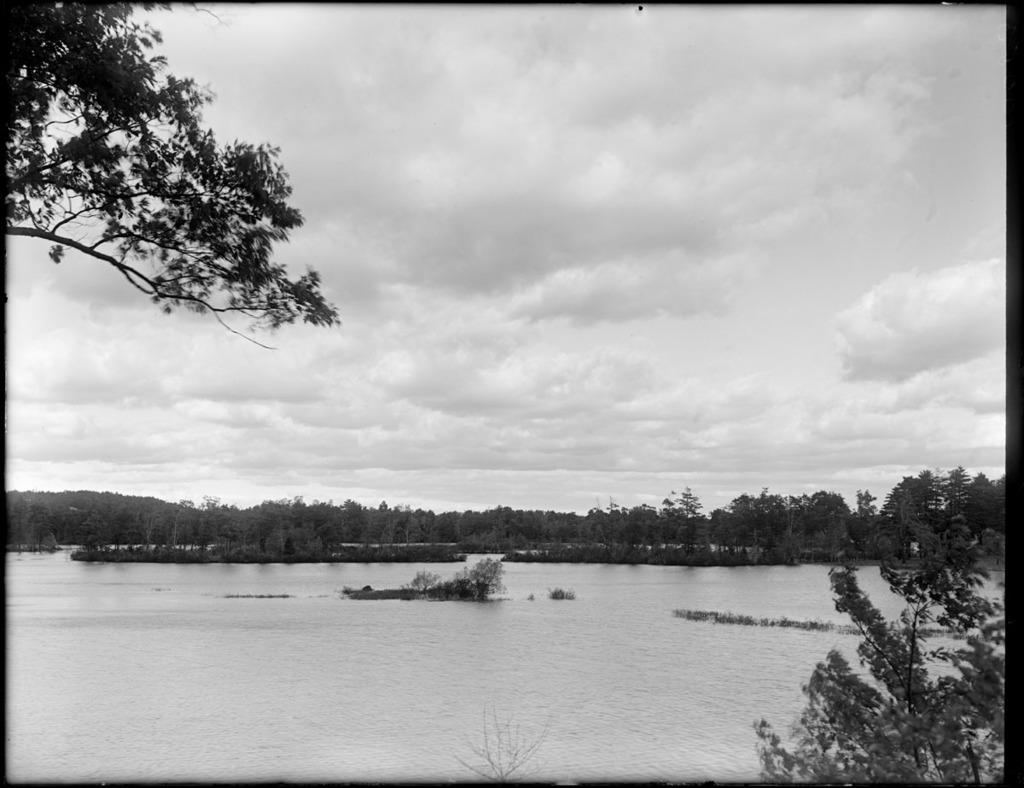What is the primary element visible in the picture? There is water in the picture. What can be seen in the background of the picture? There are trees in the background of the picture. How many turkeys are visible in the picture? There are no turkeys present in the picture; it only features water and trees in the background. What type of pleasure can be experienced by the water in the picture? The water in the picture is not capable of experiencing pleasure, as it is an inanimate object. 